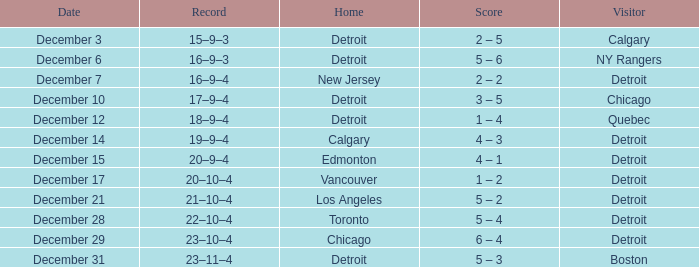What is the score on december 10? 3 – 5. Could you help me parse every detail presented in this table? {'header': ['Date', 'Record', 'Home', 'Score', 'Visitor'], 'rows': [['December 3', '15–9–3', 'Detroit', '2 – 5', 'Calgary'], ['December 6', '16–9–3', 'Detroit', '5 – 6', 'NY Rangers'], ['December 7', '16–9–4', 'New Jersey', '2 – 2', 'Detroit'], ['December 10', '17–9–4', 'Detroit', '3 – 5', 'Chicago'], ['December 12', '18–9–4', 'Detroit', '1 – 4', 'Quebec'], ['December 14', '19–9–4', 'Calgary', '4 – 3', 'Detroit'], ['December 15', '20–9–4', 'Edmonton', '4 – 1', 'Detroit'], ['December 17', '20–10–4', 'Vancouver', '1 – 2', 'Detroit'], ['December 21', '21–10–4', 'Los Angeles', '5 – 2', 'Detroit'], ['December 28', '22–10–4', 'Toronto', '5 – 4', 'Detroit'], ['December 29', '23–10–4', 'Chicago', '6 – 4', 'Detroit'], ['December 31', '23–11–4', 'Detroit', '5 – 3', 'Boston']]} 